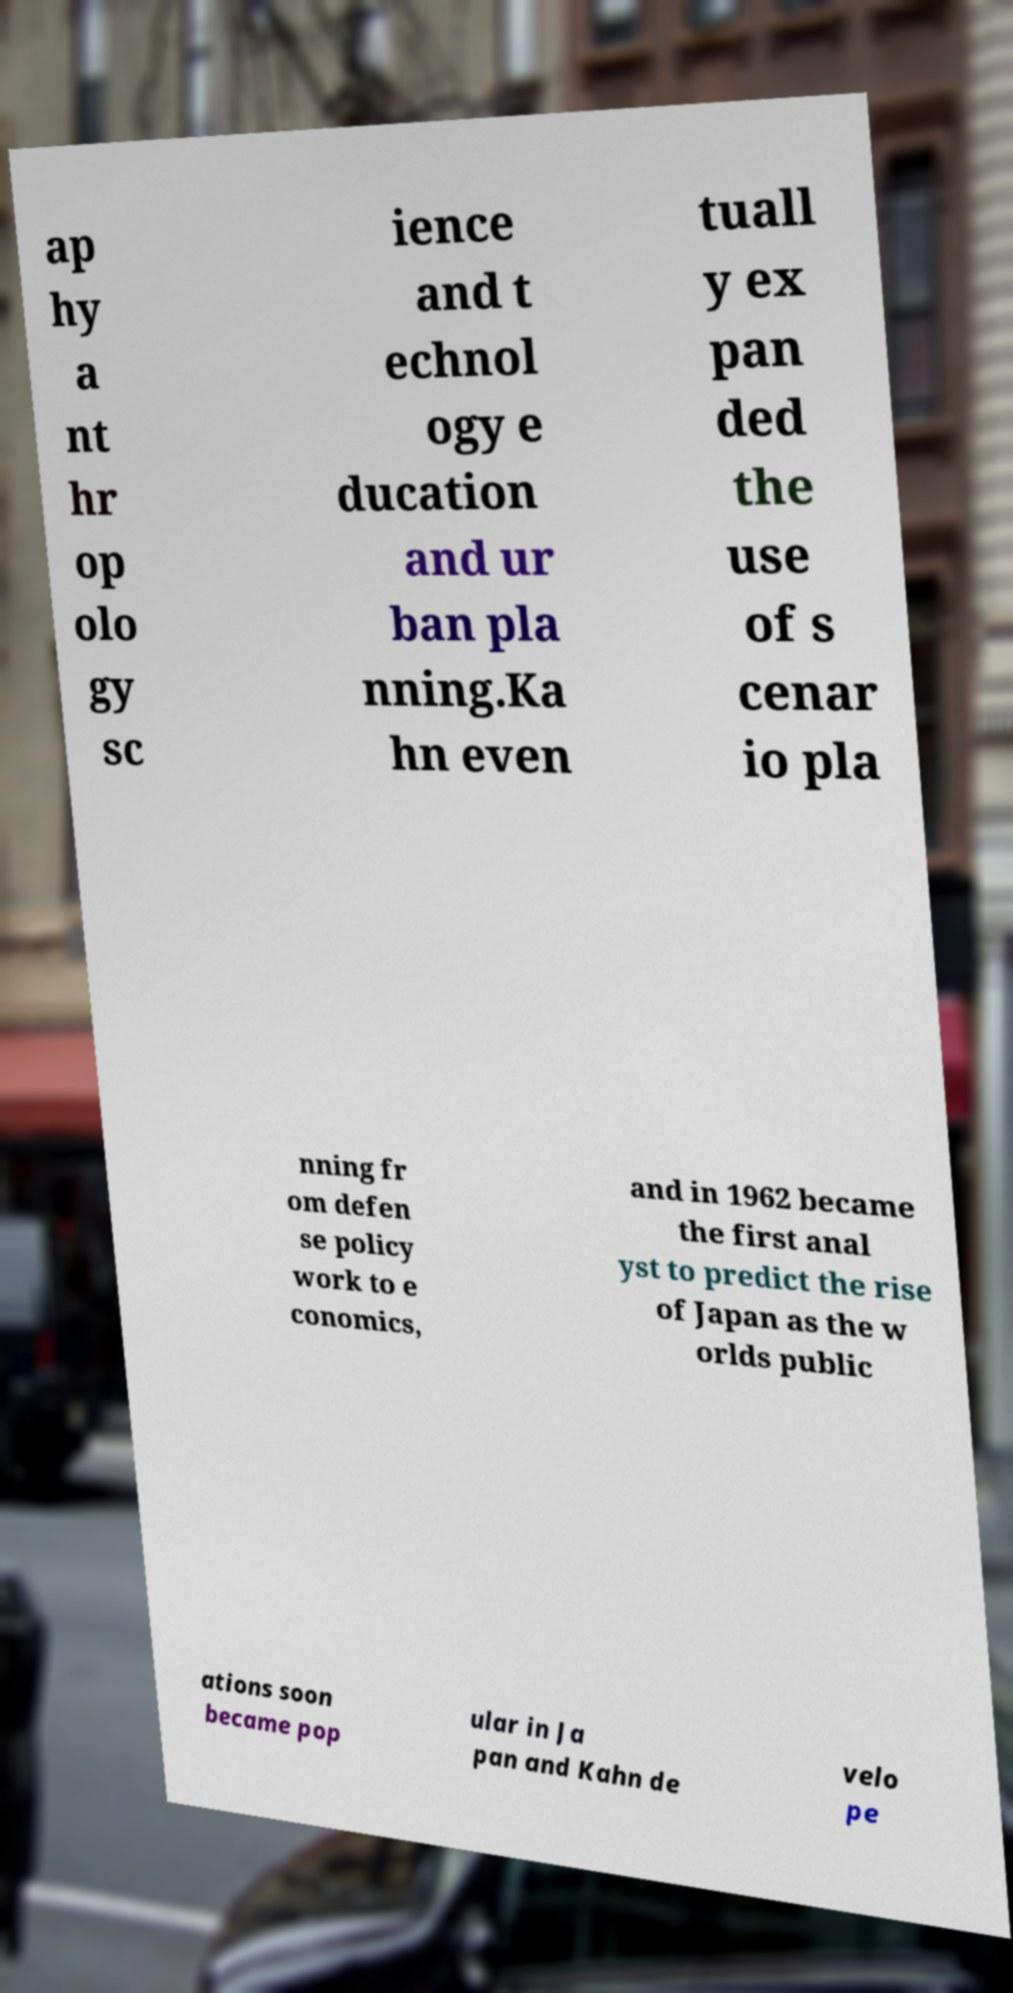There's text embedded in this image that I need extracted. Can you transcribe it verbatim? ap hy a nt hr op olo gy sc ience and t echnol ogy e ducation and ur ban pla nning.Ka hn even tuall y ex pan ded the use of s cenar io pla nning fr om defen se policy work to e conomics, and in 1962 became the first anal yst to predict the rise of Japan as the w orlds public ations soon became pop ular in Ja pan and Kahn de velo pe 